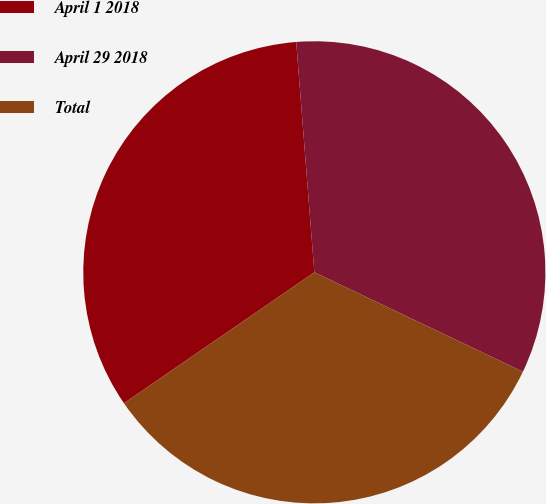Convert chart. <chart><loc_0><loc_0><loc_500><loc_500><pie_chart><fcel>April 1 2018<fcel>April 29 2018<fcel>Total<nl><fcel>33.34%<fcel>33.33%<fcel>33.33%<nl></chart> 